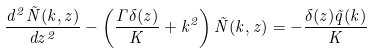Convert formula to latex. <formula><loc_0><loc_0><loc_500><loc_500>\frac { d ^ { 2 } \tilde { N } ( k , z ) } { d z ^ { 2 } } - \left ( \frac { \Gamma \delta ( z ) } { K } + k ^ { 2 } \right ) \tilde { N } ( k , z ) = - \frac { \delta ( z ) \tilde { q } ( k ) } { K }</formula> 